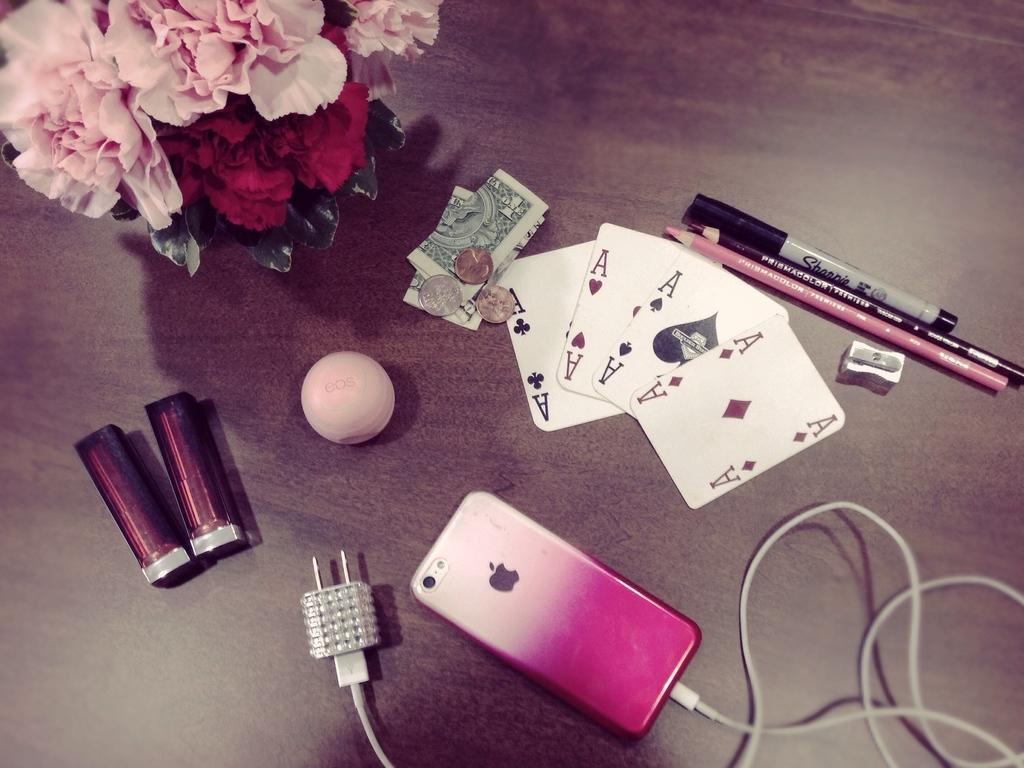What electronic device is visible in the image? There is a phone in the image. What is connected to the phone in the image? There is a cable in the image. What items can be seen on the wooden surface in the image? There are cards, flowers, coins, and currency notes on the wooden surface in the image. How does the needle compare to the size of the cat in the image? There is no needle or cat present in the image. 